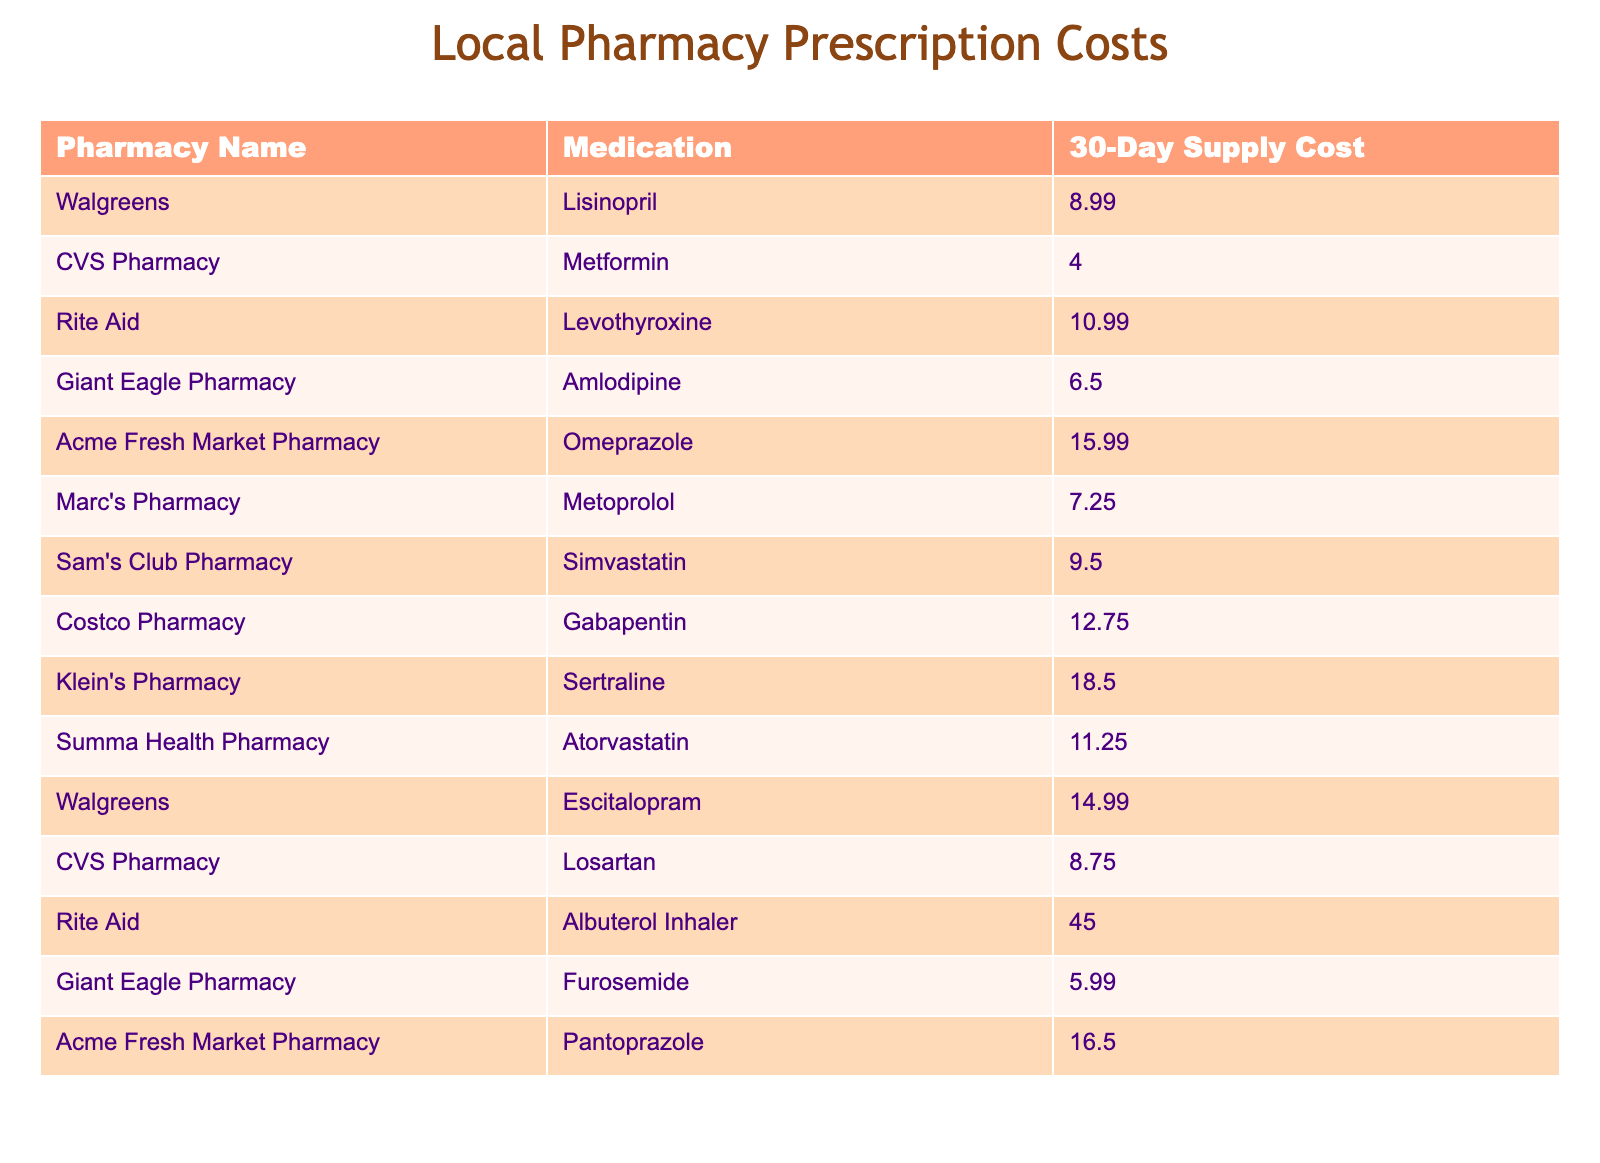What is the cost of Lisinopril at Walgreens? The table lists the cost of Lisinopril under the pharmacy name Walgreens. Directly referencing the table, it shows the 30-day supply cost for Lisinopril is 8.99.
Answer: 8.99 Which medication is the most expensive based on the table? By reviewing the "30-Day Supply Cost" column across all medications, the highest value can be identified. The data shows that the Albuterol Inhaler at Rite Aid is priced at 45.00, making it the most expensive medication.
Answer: 45.00 What is the average cost of medications at Giant Eagle Pharmacy? Looking specifically at Giant Eagle Pharmacy, the only two medications listed are Amlodipine and Furosemide, with costs of 6.50 and 5.99 respectively. To find the average, sum the two costs: 6.50 + 5.99 = 12.49, then divide by 2, which results in 12.49 / 2 = 6.245.
Answer: 6.25 Is the cost of Omeprazole at Acme Fresh Market Pharmacy greater than 12? According to the table, Omeprazole costs 15.99 at Acme Fresh Market Pharmacy. Since 15.99 is greater than 12, this statement is true.
Answer: Yes How much more expensive is Sertraline at Klein's Pharmacy compared to Simvastatin at Sam's Club Pharmacy? First, find the cost of Sertraline, which is 18.50, and Simvastatin, which costs 9.50. To determine how much more expensive Sertraline is, subtract the cost of Simvastatin from the cost of Sertraline: 18.50 - 9.50 = 9.00.
Answer: 9.00 Is the total cost for a 30-day supply of both medications at CVS Pharmacy less than 15? CVS Pharmacy has two medications listed: Metformin at 4.00 and Losartan at 8.75. Summing these gives 4.00 + 8.75 = 12.75. Since 12.75 is indeed less than 15, the answer is yes.
Answer: Yes What is the total cost of medications at Rite Aid? Only two medications are listed for Rite Aid: Levothyroxine at 10.99 and Albuterol Inhaler at 45.00. To find the total cost, add these two values together: 10.99 + 45.00 = 55.99.
Answer: 55.99 Which pharmacy offers the cheapest medication overall? Review the "30-Day Supply Cost" for each pharmacy. By identifying the medication with the lowest cost, we see Metformin at CVS Pharmacy costs 4.00, which is the lowest price among all listed medications.
Answer: 4.00 